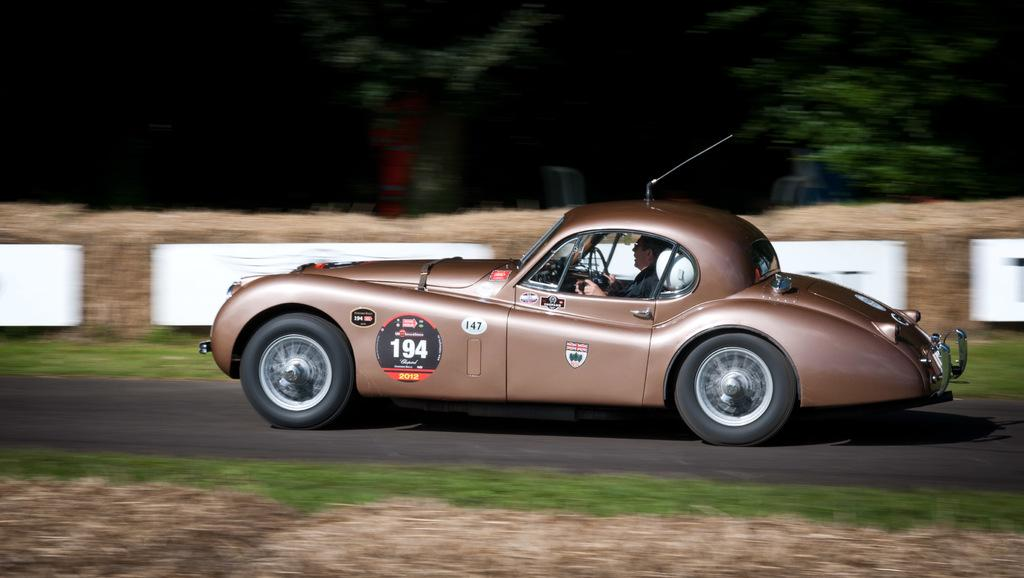What is the person in the image doing? There is a person riding a car in the image. Where is the car located? The car is on the road. What type of natural environment can be seen in the image? There is grass and trees visible in the image. What is the price of the vest that the person is wearing in the image? There is no vest visible in the image, and therefore no price can be determined. Can you tell me how many keys are hanging from the car's ignition in the image? There are no keys visible in the image, and therefore no count can be provided. 